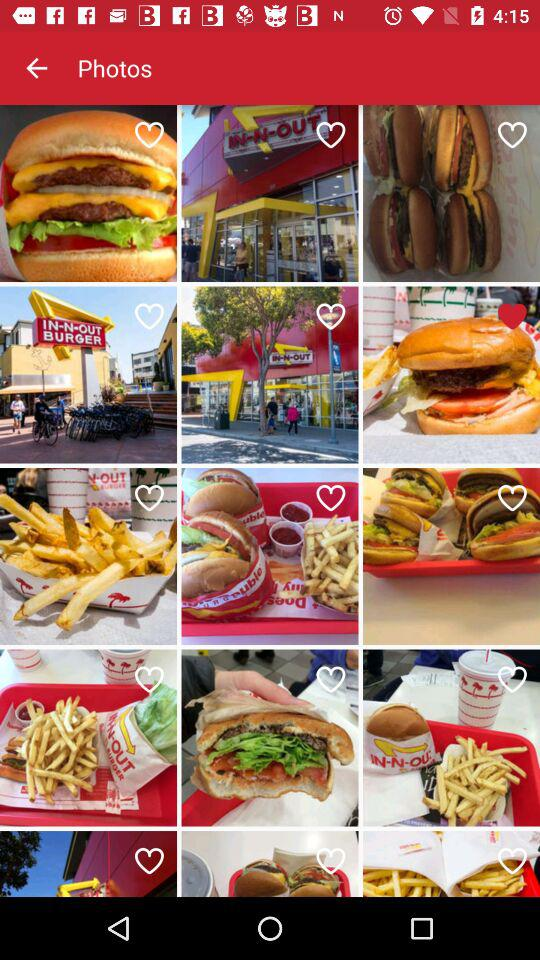What is the application name? The application name is "Photos". 